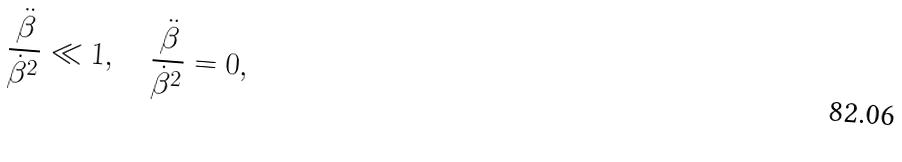<formula> <loc_0><loc_0><loc_500><loc_500>\frac { \ddot { \beta } } { \dot { \beta } ^ { 2 } } \ll 1 , \quad \frac { \ddot { \beta } } { \dot { \beta } ^ { 2 } } = 0 ,</formula> 